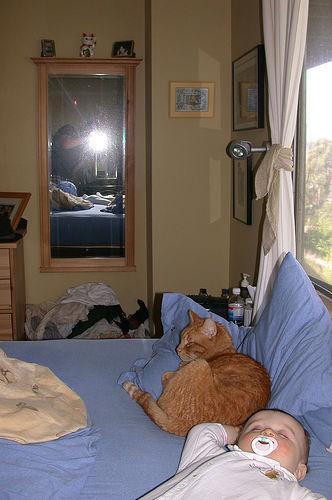How many children are on the bed?
Give a very brief answer. 1. 